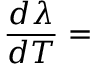Convert formula to latex. <formula><loc_0><loc_0><loc_500><loc_500>\frac { d \lambda } { d T } =</formula> 